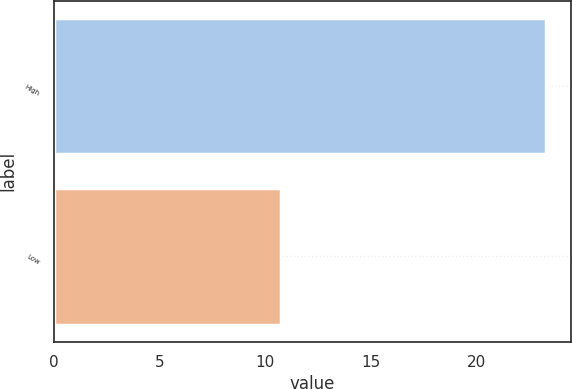Convert chart. <chart><loc_0><loc_0><loc_500><loc_500><bar_chart><fcel>High<fcel>Low<nl><fcel>23.32<fcel>10.78<nl></chart> 